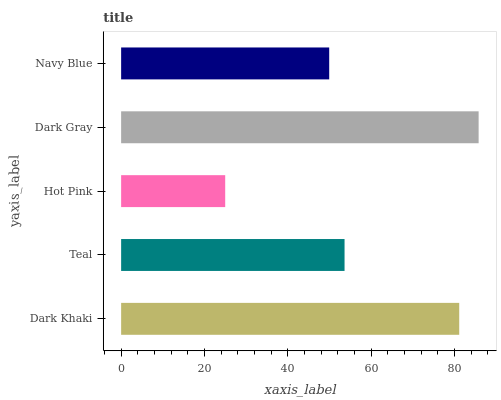Is Hot Pink the minimum?
Answer yes or no. Yes. Is Dark Gray the maximum?
Answer yes or no. Yes. Is Teal the minimum?
Answer yes or no. No. Is Teal the maximum?
Answer yes or no. No. Is Dark Khaki greater than Teal?
Answer yes or no. Yes. Is Teal less than Dark Khaki?
Answer yes or no. Yes. Is Teal greater than Dark Khaki?
Answer yes or no. No. Is Dark Khaki less than Teal?
Answer yes or no. No. Is Teal the high median?
Answer yes or no. Yes. Is Teal the low median?
Answer yes or no. Yes. Is Navy Blue the high median?
Answer yes or no. No. Is Navy Blue the low median?
Answer yes or no. No. 